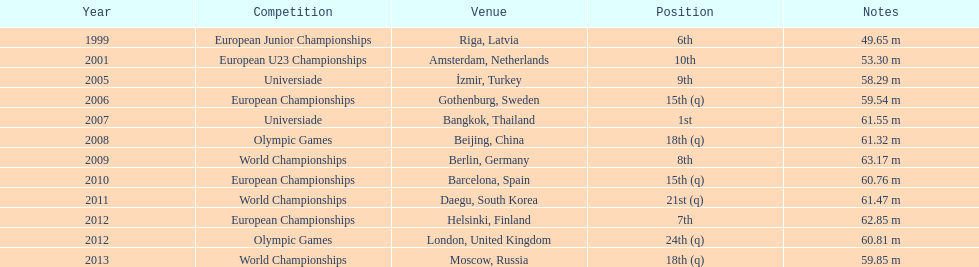How many world titles has he competed in? 3. 